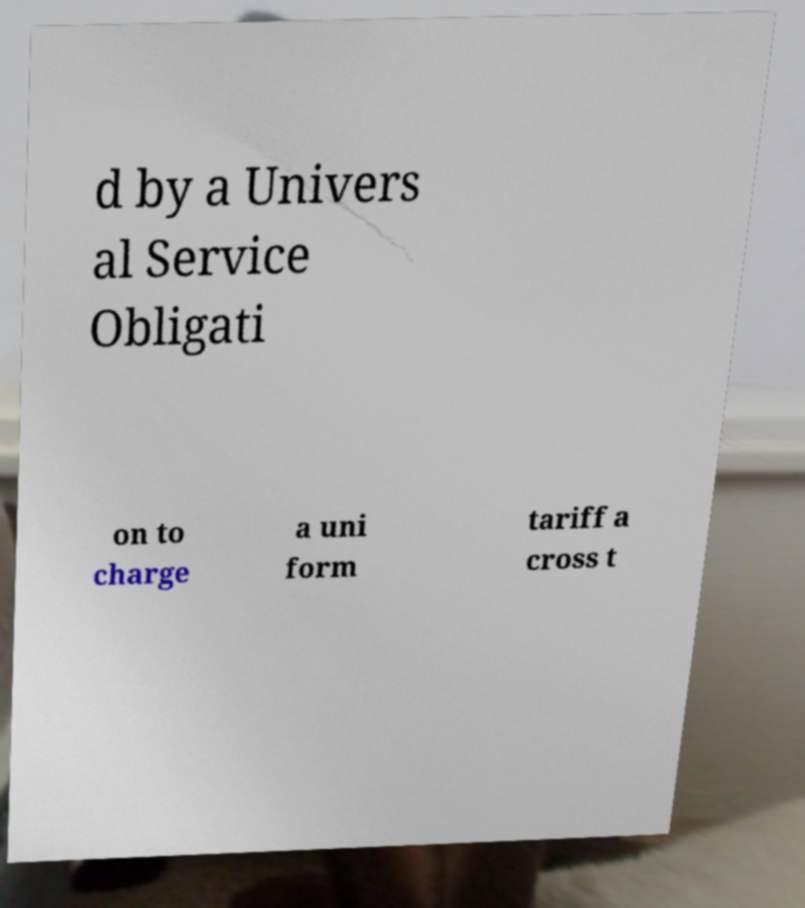For documentation purposes, I need the text within this image transcribed. Could you provide that? d by a Univers al Service Obligati on to charge a uni form tariff a cross t 